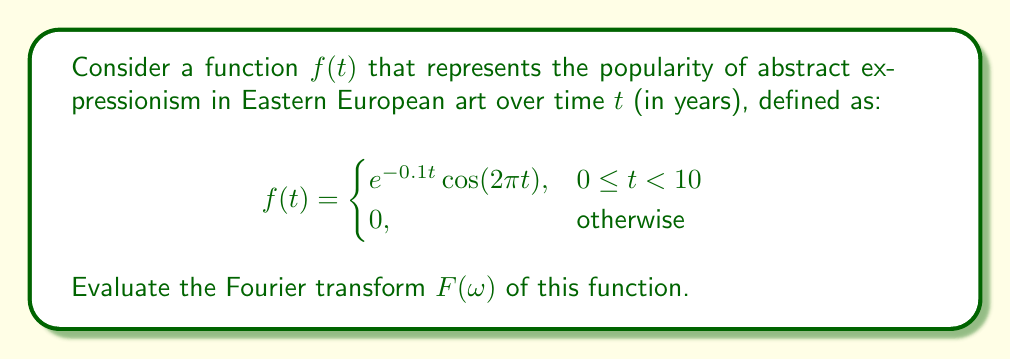Can you solve this math problem? To solve this problem, we'll follow these steps:

1) The Fourier transform is defined as:

   $$F(\omega) = \int_{-\infty}^{\infty} f(t) e^{-i\omega t} dt$$

2) Given our function $f(t)$, we can rewrite the integral as:

   $$F(\omega) = \int_{0}^{10} e^{-0.1t} \cos(2\pi t) e^{-i\omega t} dt$$

3) We can rewrite the cosine function using Euler's formula:

   $$\cos(2\pi t) = \frac{e^{i2\pi t} + e^{-i2\pi t}}{2}$$

4) Substituting this into our integral:

   $$F(\omega) = \frac{1}{2} \int_{0}^{10} e^{-0.1t} (e^{i2\pi t} + e^{-i2\pi t}) e^{-i\omega t} dt$$

5) Simplifying:

   $$F(\omega) = \frac{1}{2} \int_{0}^{10} (e^{(-0.1+i2\pi-i\omega)t} + e^{(-0.1-i2\pi-i\omega)t}) dt$$

6) Integrating:

   $$F(\omega) = \frac{1}{2} \left[ \frac{e^{(-0.1+i2\pi-i\omega)t}}{-0.1+i2\pi-i\omega} + \frac{e^{(-0.1-i2\pi-i\omega)t}}{-0.1-i2\pi-i\omega} \right]_{0}^{10}$$

7) Evaluating the limits:

   $$F(\omega) = \frac{1}{2} \left[ \frac{e^{(-0.1+i2\pi-i\omega)10} - 1}{-0.1+i2\pi-i\omega} + \frac{e^{(-0.1-i2\pi-i\omega)10} - 1}{-0.1-i2\pi-i\omega} \right]$$

8) This is the final form of the Fourier transform $F(\omega)$.
Answer: $$F(\omega) = \frac{1}{2} \left[ \frac{e^{(-0.1+i2\pi-i\omega)10} - 1}{-0.1+i2\pi-i\omega} + \frac{e^{(-0.1-i2\pi-i\omega)10} - 1}{-0.1-i2\pi-i\omega} \right]$$ 